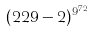<formula> <loc_0><loc_0><loc_500><loc_500>( 2 2 9 - 2 ) ^ { 9 ^ { 7 2 } }</formula> 